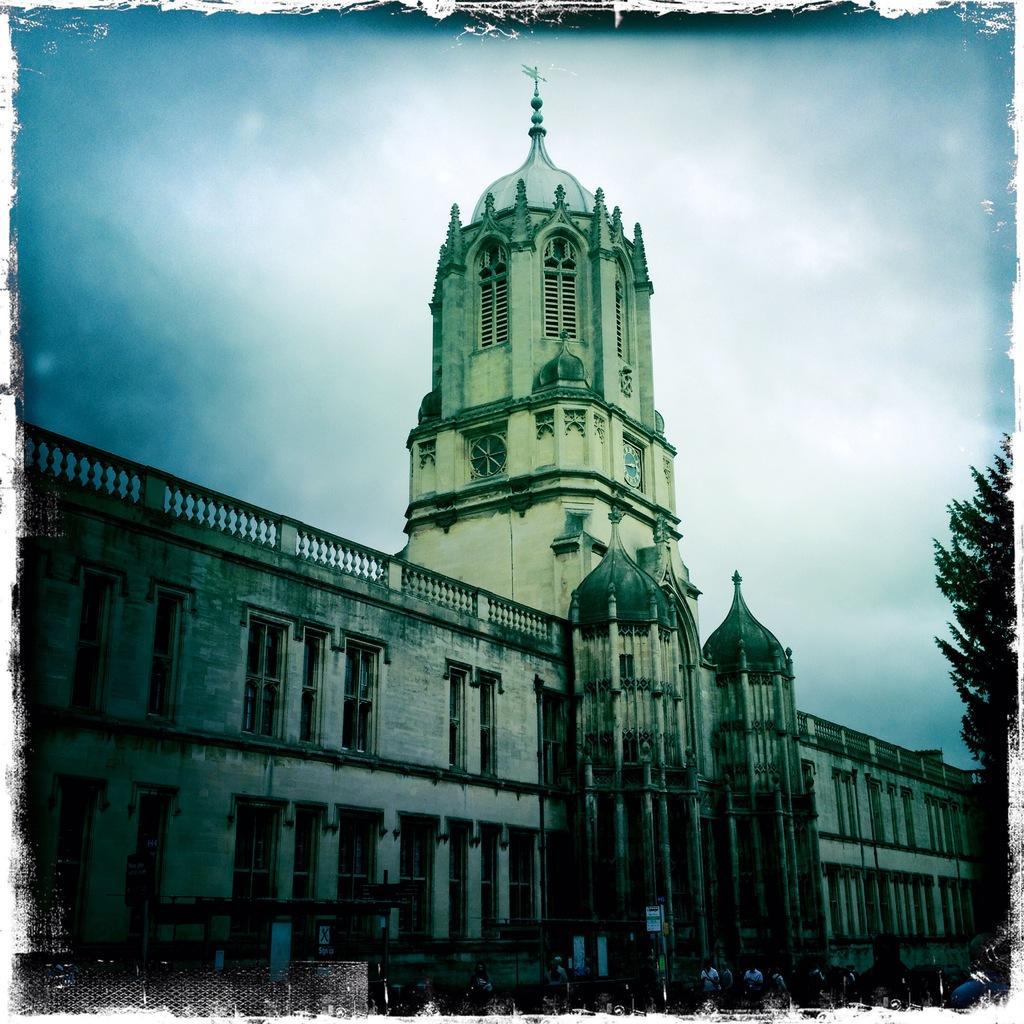How would you summarize this image in a sentence or two? In this image there is a building and in front of the building there are people standing on the road. At the right side of the image there is a tree and at the background there is sky. 